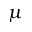Convert formula to latex. <formula><loc_0><loc_0><loc_500><loc_500>\mu</formula> 